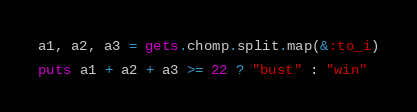Convert code to text. <code><loc_0><loc_0><loc_500><loc_500><_Ruby_>a1, a2, a3 = gets.chomp.split.map(&:to_i)

puts a1 + a2 + a3 >= 22 ? "bust" : "win"</code> 